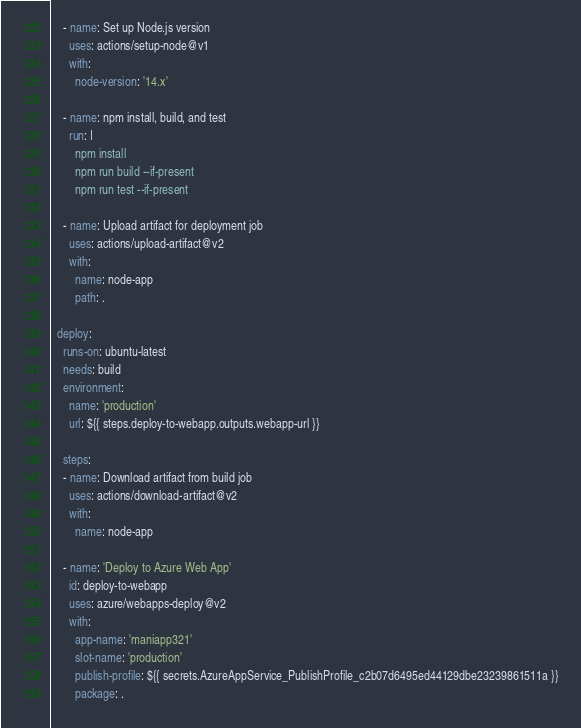<code> <loc_0><loc_0><loc_500><loc_500><_YAML_>    - name: Set up Node.js version
      uses: actions/setup-node@v1
      with:
        node-version: '14.x'

    - name: npm install, build, and test
      run: |
        npm install
        npm run build --if-present
        npm run test --if-present

    - name: Upload artifact for deployment job
      uses: actions/upload-artifact@v2
      with:
        name: node-app
        path: .

  deploy:
    runs-on: ubuntu-latest
    needs: build
    environment:
      name: 'production'
      url: ${{ steps.deploy-to-webapp.outputs.webapp-url }}

    steps:
    - name: Download artifact from build job
      uses: actions/download-artifact@v2
      with:
        name: node-app

    - name: 'Deploy to Azure Web App'
      id: deploy-to-webapp
      uses: azure/webapps-deploy@v2
      with:
        app-name: 'maniapp321'
        slot-name: 'production'
        publish-profile: ${{ secrets.AzureAppService_PublishProfile_c2b07d6495ed44129dbe23239861511a }}
        package: .</code> 